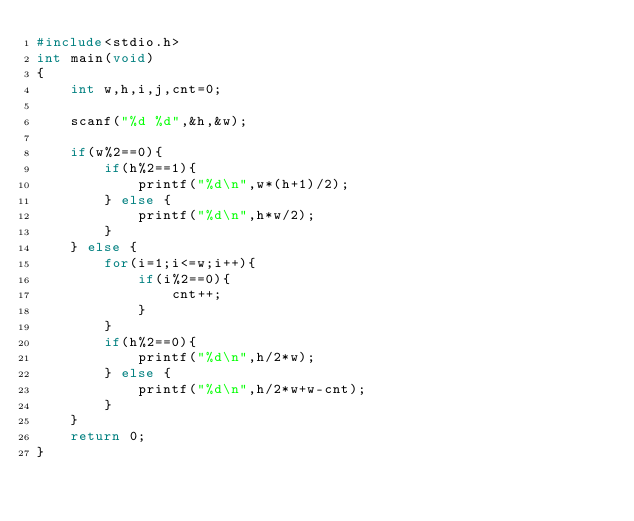Convert code to text. <code><loc_0><loc_0><loc_500><loc_500><_C++_>#include<stdio.h>
int main(void)
{
    int w,h,i,j,cnt=0;

    scanf("%d %d",&h,&w);

    if(w%2==0){
        if(h%2==1){
            printf("%d\n",w*(h+1)/2);
        } else {
            printf("%d\n",h*w/2);
        }
    } else {
        for(i=1;i<=w;i++){
            if(i%2==0){
                cnt++;
            }
        }
        if(h%2==0){
            printf("%d\n",h/2*w);
        } else {
            printf("%d\n",h/2*w+w-cnt);
        }
    }
    return 0;
}</code> 